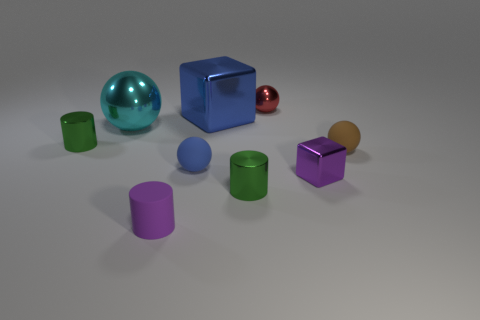Subtract all blue balls. How many balls are left? 3 Subtract all matte cylinders. How many cylinders are left? 2 Add 1 big green shiny cylinders. How many objects exist? 10 Subtract all gray spheres. Subtract all gray blocks. How many spheres are left? 4 Subtract all balls. How many objects are left? 5 Add 7 blue metal cylinders. How many blue metal cylinders exist? 7 Subtract 1 blue blocks. How many objects are left? 8 Subtract all large cyan metallic objects. Subtract all small brown matte objects. How many objects are left? 7 Add 1 tiny red shiny balls. How many tiny red shiny balls are left? 2 